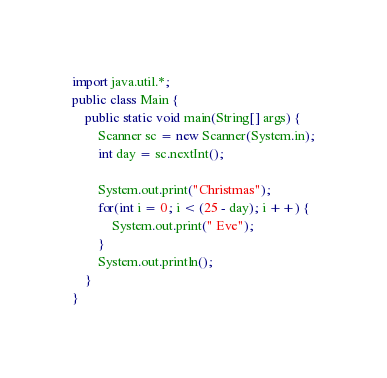Convert code to text. <code><loc_0><loc_0><loc_500><loc_500><_Java_>import java.util.*;
public class Main {
	public static void main(String[] args) {
		Scanner sc = new Scanner(System.in);
		int day = sc.nextInt();

		System.out.print("Christmas");
		for(int i = 0; i < (25 - day); i ++) {
			System.out.print(" Eve");
		}
		System.out.println();
	}
}</code> 